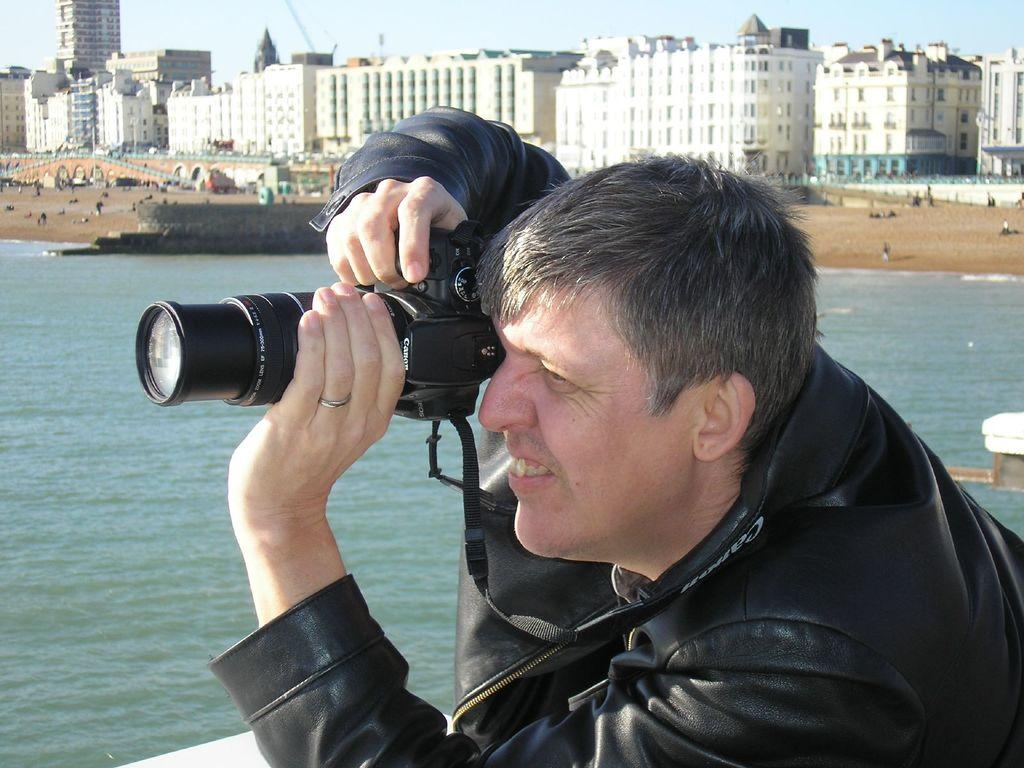What is the main subject of the image? There is a man in the image. What is the man wearing? The man is wearing a black jacket. What is the man holding in the image? The man is holding a camera. What can be seen in the background of the image? Water, land, buildings, and the sky are visible in the background of the image. Can you see an owl perched on the man's shoulder in the image? No, there is no owl present in the image. Is the man holding an umbrella in the image? No, the man is holding a camera, not an umbrella. 